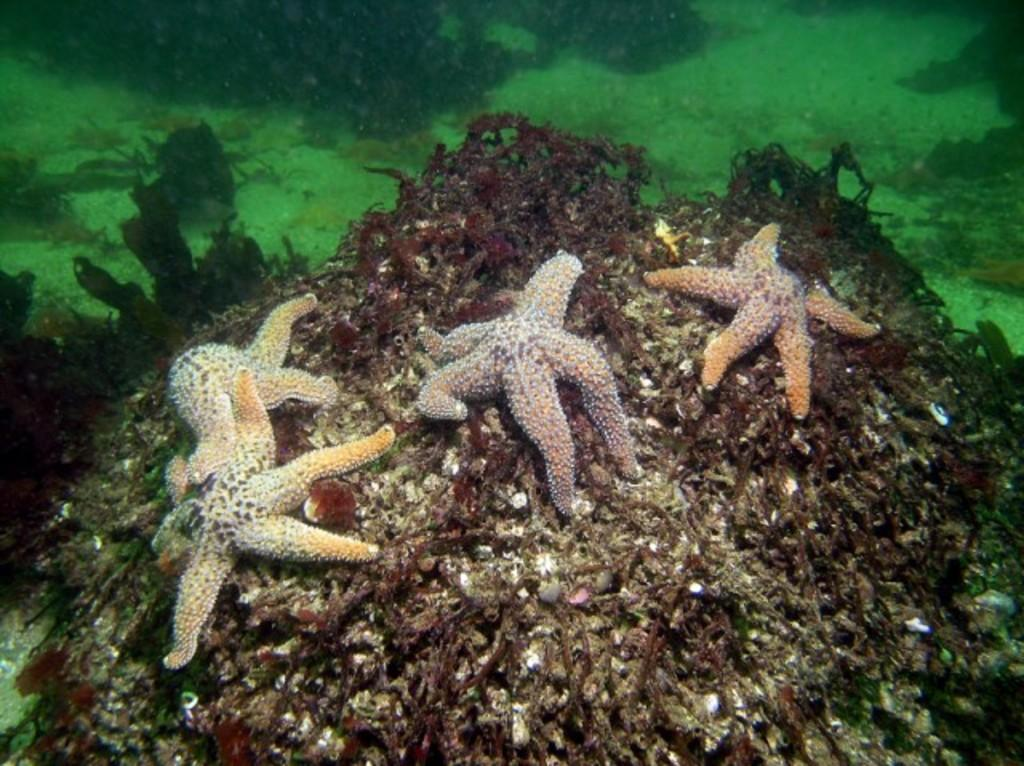What is the primary element visible in the image? There is water in the image. What types of animals can be seen in the water? Aquatic animals are present in the image. Where is the cactus located in the image? There is no cactus present in the image. What type of door can be seen in the image? There is no door present in the image. 